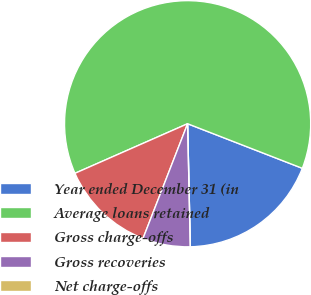Convert chart to OTSL. <chart><loc_0><loc_0><loc_500><loc_500><pie_chart><fcel>Year ended December 31 (in<fcel>Average loans retained<fcel>Gross charge-offs<fcel>Gross recoveries<fcel>Net charge-offs<nl><fcel>18.75%<fcel>62.49%<fcel>12.5%<fcel>6.25%<fcel>0.0%<nl></chart> 